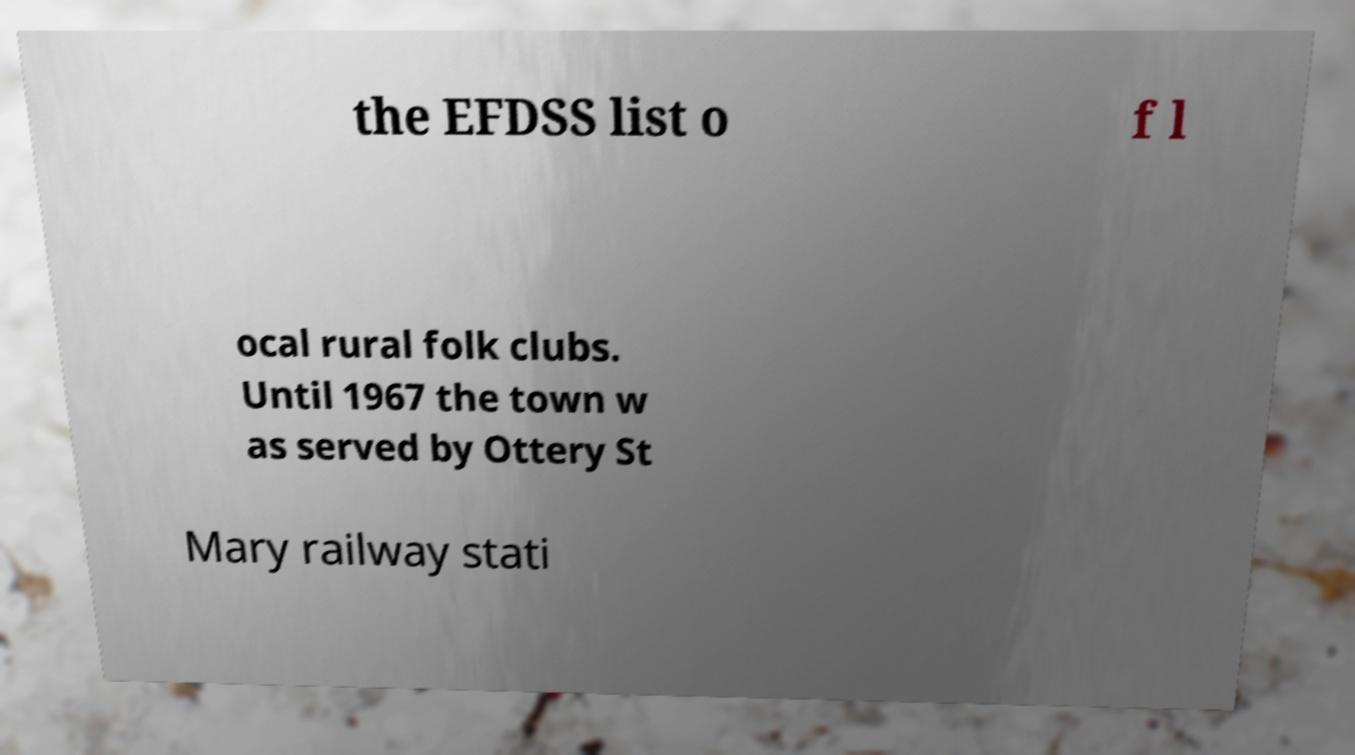Can you accurately transcribe the text from the provided image for me? the EFDSS list o f l ocal rural folk clubs. Until 1967 the town w as served by Ottery St Mary railway stati 